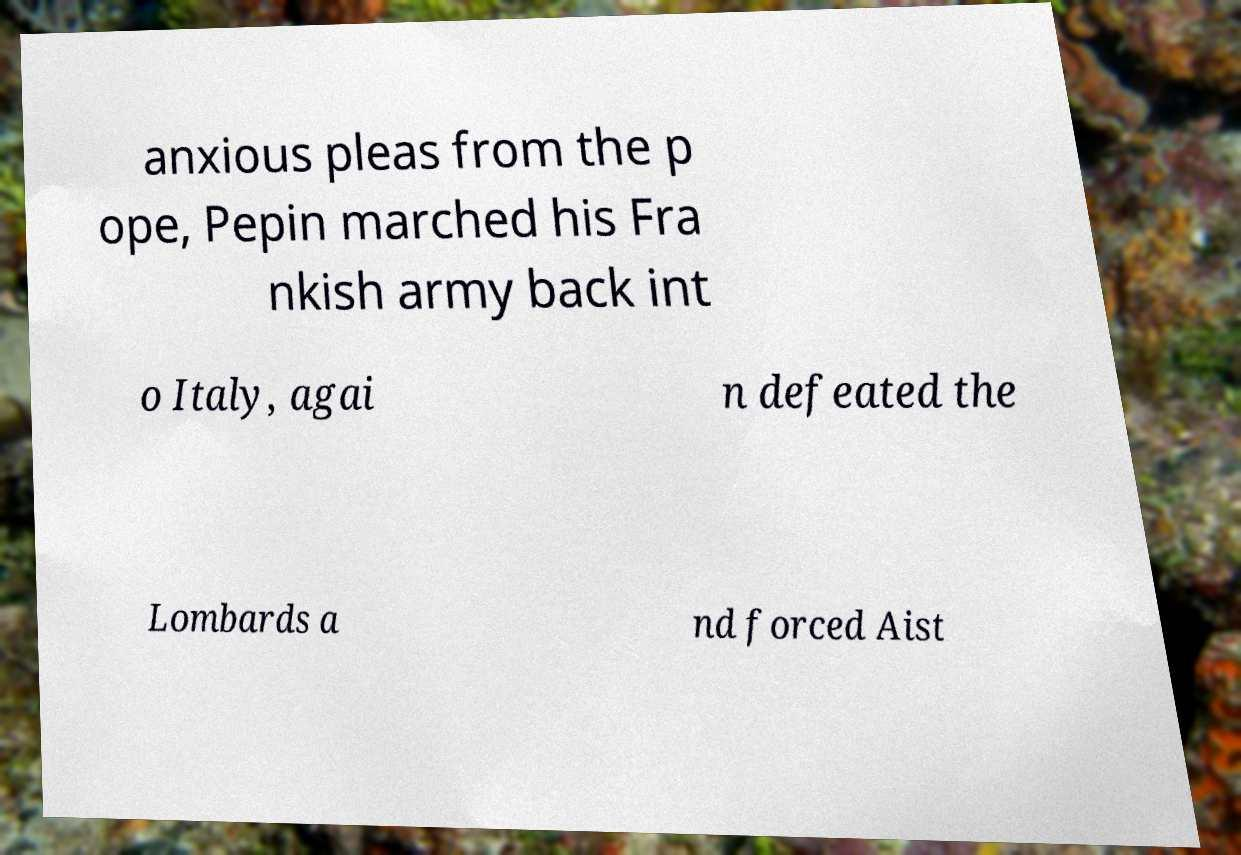What messages or text are displayed in this image? I need them in a readable, typed format. anxious pleas from the p ope, Pepin marched his Fra nkish army back int o Italy, agai n defeated the Lombards a nd forced Aist 